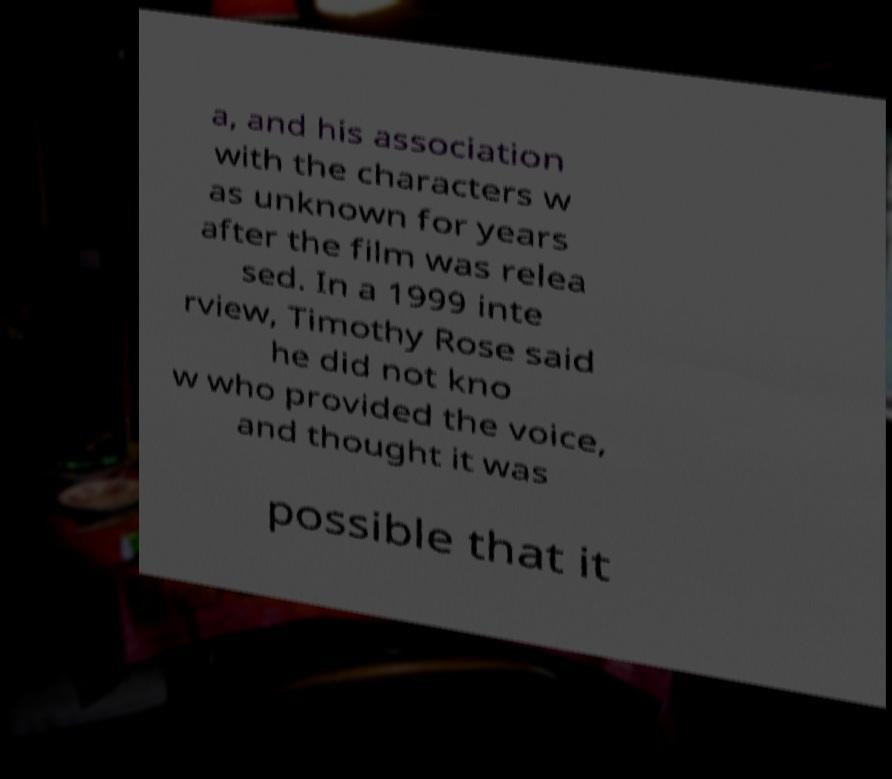For documentation purposes, I need the text within this image transcribed. Could you provide that? a, and his association with the characters w as unknown for years after the film was relea sed. In a 1999 inte rview, Timothy Rose said he did not kno w who provided the voice, and thought it was possible that it 